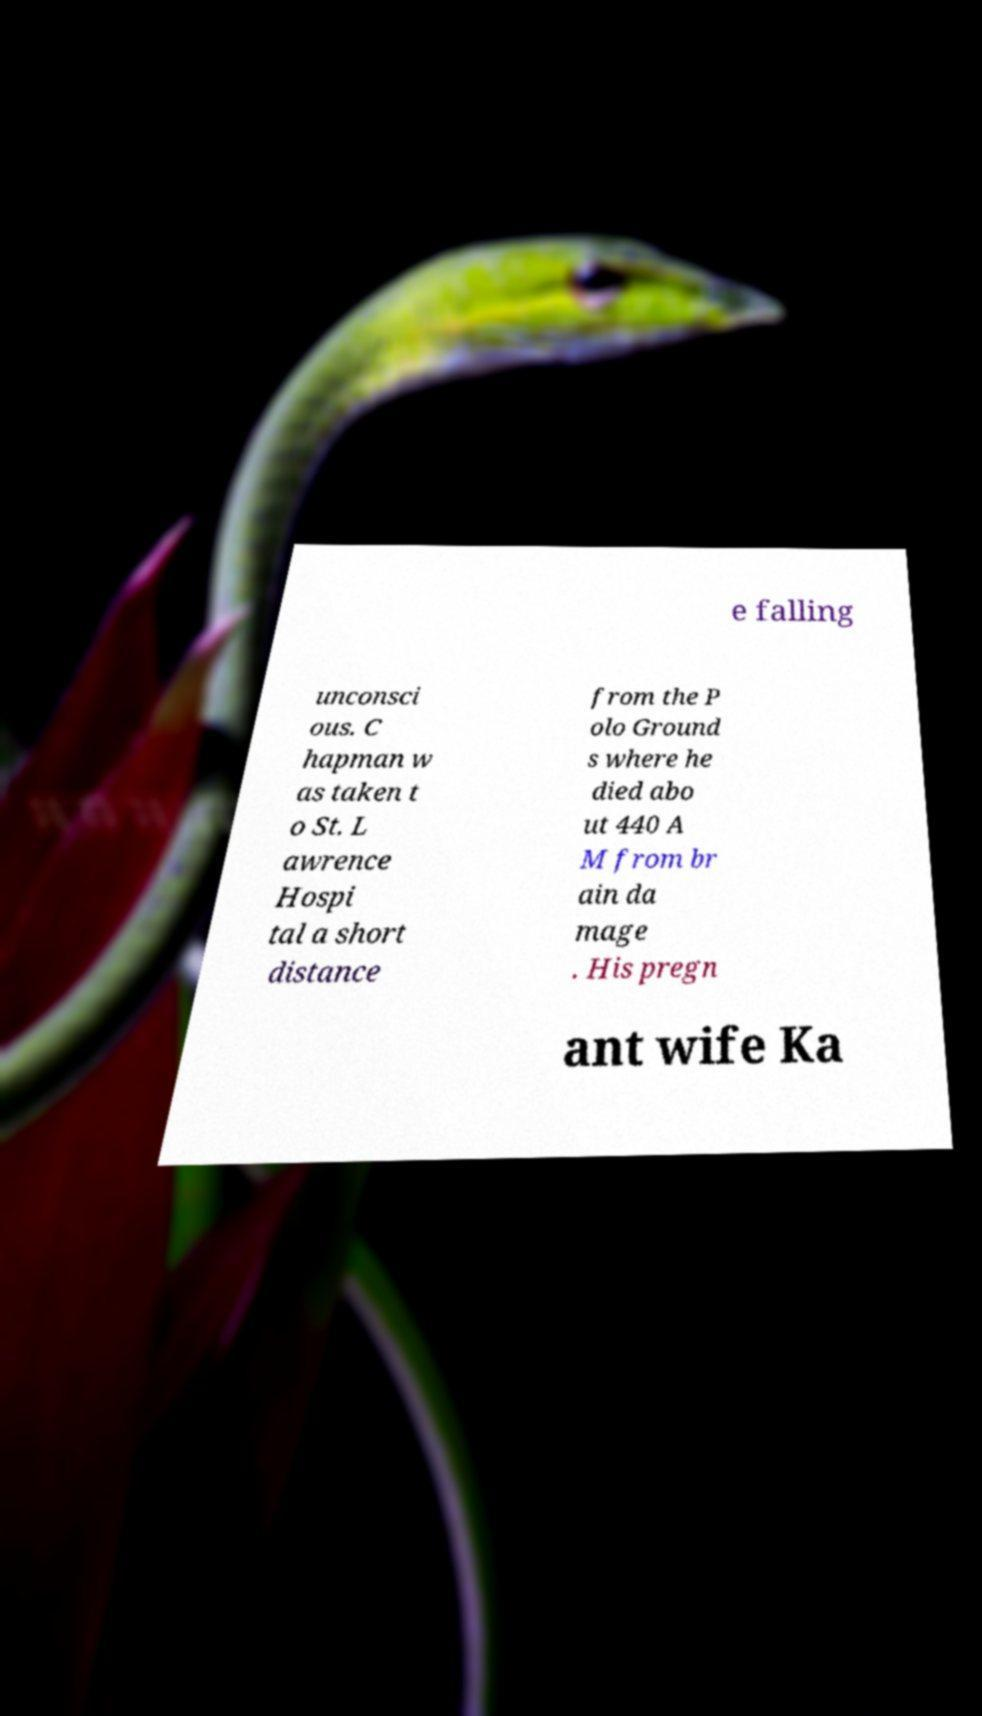There's text embedded in this image that I need extracted. Can you transcribe it verbatim? e falling unconsci ous. C hapman w as taken t o St. L awrence Hospi tal a short distance from the P olo Ground s where he died abo ut 440 A M from br ain da mage . His pregn ant wife Ka 